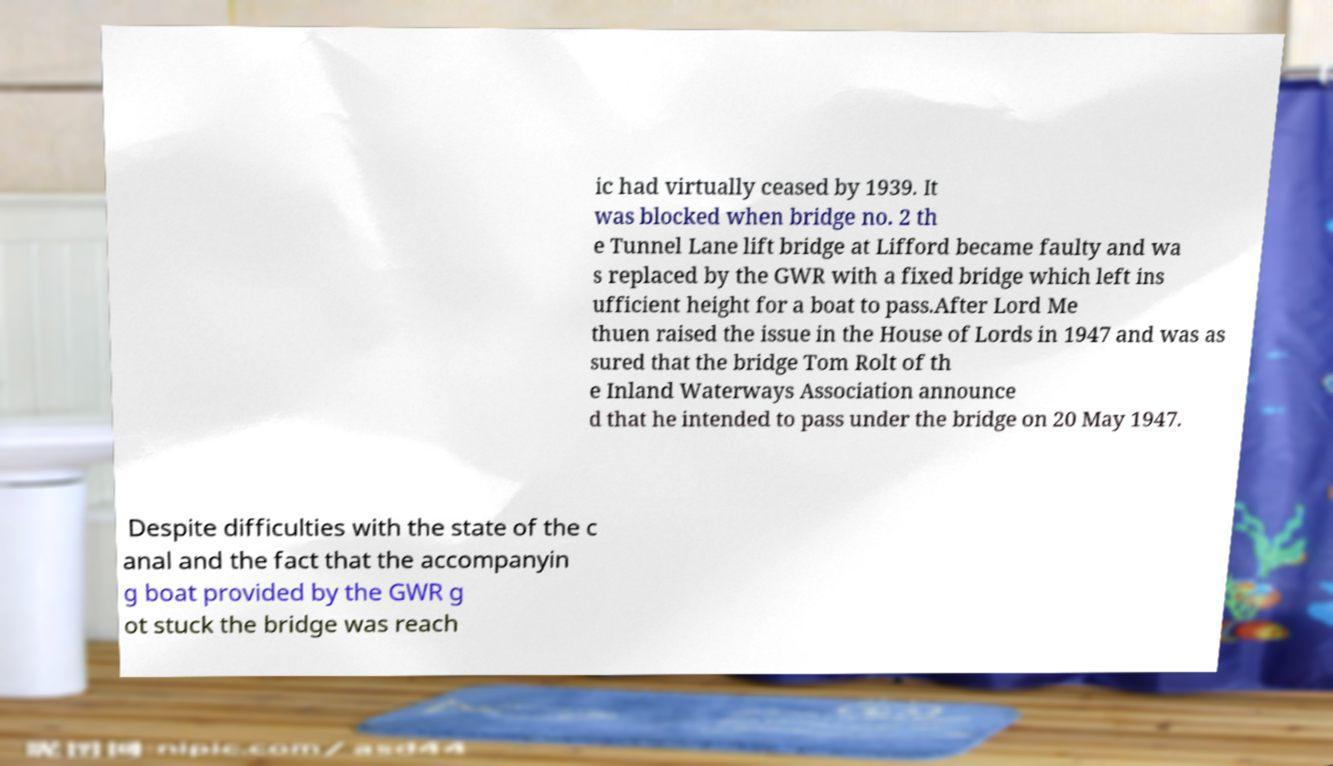Please identify and transcribe the text found in this image. ic had virtually ceased by 1939. It was blocked when bridge no. 2 th e Tunnel Lane lift bridge at Lifford became faulty and wa s replaced by the GWR with a fixed bridge which left ins ufficient height for a boat to pass.After Lord Me thuen raised the issue in the House of Lords in 1947 and was as sured that the bridge Tom Rolt of th e Inland Waterways Association announce d that he intended to pass under the bridge on 20 May 1947. Despite difficulties with the state of the c anal and the fact that the accompanyin g boat provided by the GWR g ot stuck the bridge was reach 